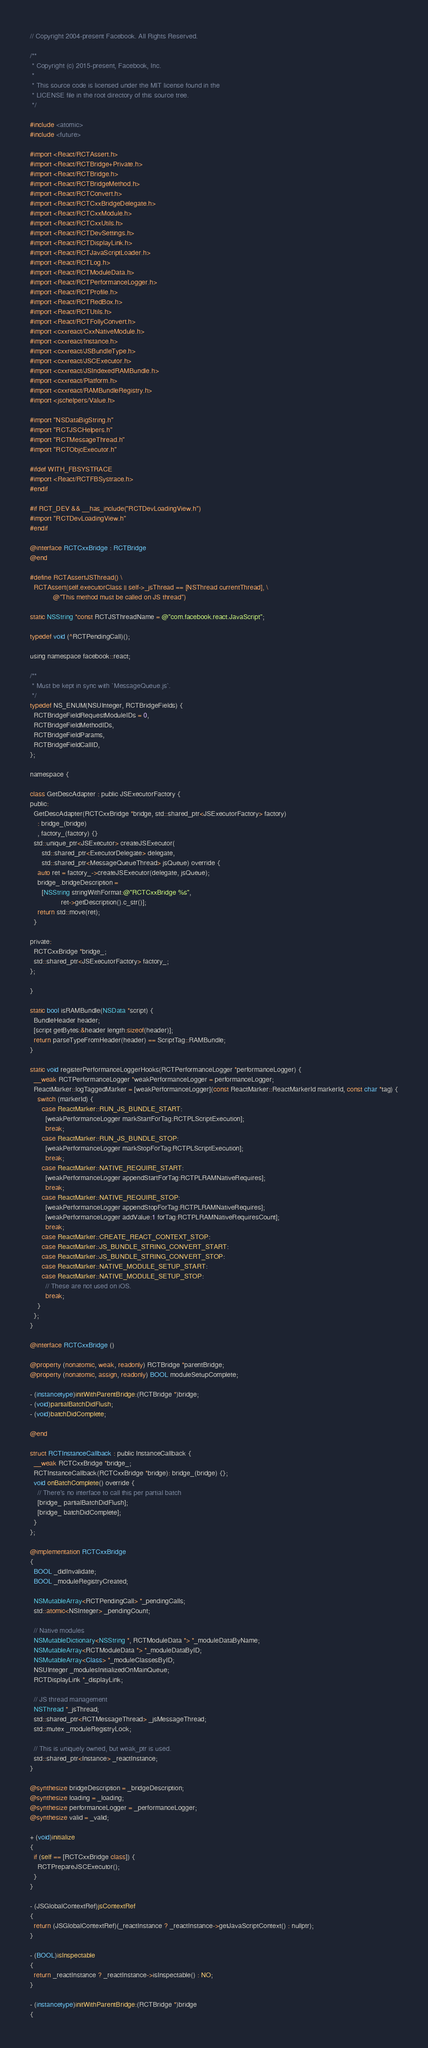<code> <loc_0><loc_0><loc_500><loc_500><_ObjectiveC_>// Copyright 2004-present Facebook. All Rights Reserved.

/**
 * Copyright (c) 2015-present, Facebook, Inc.
 *
 * This source code is licensed under the MIT license found in the
 * LICENSE file in the root directory of this source tree.
 */

#include <atomic>
#include <future>

#import <React/RCTAssert.h>
#import <React/RCTBridge+Private.h>
#import <React/RCTBridge.h>
#import <React/RCTBridgeMethod.h>
#import <React/RCTConvert.h>
#import <React/RCTCxxBridgeDelegate.h>
#import <React/RCTCxxModule.h>
#import <React/RCTCxxUtils.h>
#import <React/RCTDevSettings.h>
#import <React/RCTDisplayLink.h>
#import <React/RCTJavaScriptLoader.h>
#import <React/RCTLog.h>
#import <React/RCTModuleData.h>
#import <React/RCTPerformanceLogger.h>
#import <React/RCTProfile.h>
#import <React/RCTRedBox.h>
#import <React/RCTUtils.h>
#import <React/RCTFollyConvert.h>
#import <cxxreact/CxxNativeModule.h>
#import <cxxreact/Instance.h>
#import <cxxreact/JSBundleType.h>
#import <cxxreact/JSCExecutor.h>
#import <cxxreact/JSIndexedRAMBundle.h>
#import <cxxreact/Platform.h>
#import <cxxreact/RAMBundleRegistry.h>
#import <jschelpers/Value.h>

#import "NSDataBigString.h"
#import "RCTJSCHelpers.h"
#import "RCTMessageThread.h"
#import "RCTObjcExecutor.h"

#ifdef WITH_FBSYSTRACE
#import <React/RCTFBSystrace.h>
#endif

#if RCT_DEV && __has_include("RCTDevLoadingView.h")
#import "RCTDevLoadingView.h"
#endif

@interface RCTCxxBridge : RCTBridge
@end

#define RCTAssertJSThread() \
  RCTAssert(self.executorClass || self->_jsThread == [NSThread currentThread], \
            @"This method must be called on JS thread")

static NSString *const RCTJSThreadName = @"com.facebook.react.JavaScript";

typedef void (^RCTPendingCall)();

using namespace facebook::react;

/**
 * Must be kept in sync with `MessageQueue.js`.
 */
typedef NS_ENUM(NSUInteger, RCTBridgeFields) {
  RCTBridgeFieldRequestModuleIDs = 0,
  RCTBridgeFieldMethodIDs,
  RCTBridgeFieldParams,
  RCTBridgeFieldCallID,
};

namespace {

class GetDescAdapter : public JSExecutorFactory {
public:
  GetDescAdapter(RCTCxxBridge *bridge, std::shared_ptr<JSExecutorFactory> factory)
    : bridge_(bridge)
    , factory_(factory) {}
  std::unique_ptr<JSExecutor> createJSExecutor(
      std::shared_ptr<ExecutorDelegate> delegate,
      std::shared_ptr<MessageQueueThread> jsQueue) override {
    auto ret = factory_->createJSExecutor(delegate, jsQueue);
    bridge_.bridgeDescription =
      [NSString stringWithFormat:@"RCTCxxBridge %s",
                ret->getDescription().c_str()];
    return std::move(ret);
  }

private:
  RCTCxxBridge *bridge_;
  std::shared_ptr<JSExecutorFactory> factory_;
};

}

static bool isRAMBundle(NSData *script) {
  BundleHeader header;
  [script getBytes:&header length:sizeof(header)];
  return parseTypeFromHeader(header) == ScriptTag::RAMBundle;
}

static void registerPerformanceLoggerHooks(RCTPerformanceLogger *performanceLogger) {
  __weak RCTPerformanceLogger *weakPerformanceLogger = performanceLogger;
  ReactMarker::logTaggedMarker = [weakPerformanceLogger](const ReactMarker::ReactMarkerId markerId, const char *tag) {
    switch (markerId) {
      case ReactMarker::RUN_JS_BUNDLE_START:
        [weakPerformanceLogger markStartForTag:RCTPLScriptExecution];
        break;
      case ReactMarker::RUN_JS_BUNDLE_STOP:
        [weakPerformanceLogger markStopForTag:RCTPLScriptExecution];
        break;
      case ReactMarker::NATIVE_REQUIRE_START:
        [weakPerformanceLogger appendStartForTag:RCTPLRAMNativeRequires];
        break;
      case ReactMarker::NATIVE_REQUIRE_STOP:
        [weakPerformanceLogger appendStopForTag:RCTPLRAMNativeRequires];
        [weakPerformanceLogger addValue:1 forTag:RCTPLRAMNativeRequiresCount];
        break;
      case ReactMarker::CREATE_REACT_CONTEXT_STOP:
      case ReactMarker::JS_BUNDLE_STRING_CONVERT_START:
      case ReactMarker::JS_BUNDLE_STRING_CONVERT_STOP:
      case ReactMarker::NATIVE_MODULE_SETUP_START:
      case ReactMarker::NATIVE_MODULE_SETUP_STOP:
        // These are not used on iOS.
        break;
    }
  };
}

@interface RCTCxxBridge ()

@property (nonatomic, weak, readonly) RCTBridge *parentBridge;
@property (nonatomic, assign, readonly) BOOL moduleSetupComplete;

- (instancetype)initWithParentBridge:(RCTBridge *)bridge;
- (void)partialBatchDidFlush;
- (void)batchDidComplete;

@end

struct RCTInstanceCallback : public InstanceCallback {
  __weak RCTCxxBridge *bridge_;
  RCTInstanceCallback(RCTCxxBridge *bridge): bridge_(bridge) {};
  void onBatchComplete() override {
    // There's no interface to call this per partial batch
    [bridge_ partialBatchDidFlush];
    [bridge_ batchDidComplete];
  }
};

@implementation RCTCxxBridge
{
  BOOL _didInvalidate;
  BOOL _moduleRegistryCreated;

  NSMutableArray<RCTPendingCall> *_pendingCalls;
  std::atomic<NSInteger> _pendingCount;

  // Native modules
  NSMutableDictionary<NSString *, RCTModuleData *> *_moduleDataByName;
  NSMutableArray<RCTModuleData *> *_moduleDataByID;
  NSMutableArray<Class> *_moduleClassesByID;
  NSUInteger _modulesInitializedOnMainQueue;
  RCTDisplayLink *_displayLink;

  // JS thread management
  NSThread *_jsThread;
  std::shared_ptr<RCTMessageThread> _jsMessageThread;
  std::mutex _moduleRegistryLock;

  // This is uniquely owned, but weak_ptr is used.
  std::shared_ptr<Instance> _reactInstance;
}

@synthesize bridgeDescription = _bridgeDescription;
@synthesize loading = _loading;
@synthesize performanceLogger = _performanceLogger;
@synthesize valid = _valid;

+ (void)initialize
{
  if (self == [RCTCxxBridge class]) {
    RCTPrepareJSCExecutor();
  }
}

- (JSGlobalContextRef)jsContextRef
{
  return (JSGlobalContextRef)(_reactInstance ? _reactInstance->getJavaScriptContext() : nullptr);
}

- (BOOL)isInspectable
{
  return _reactInstance ? _reactInstance->isInspectable() : NO;
}

- (instancetype)initWithParentBridge:(RCTBridge *)bridge
{</code> 